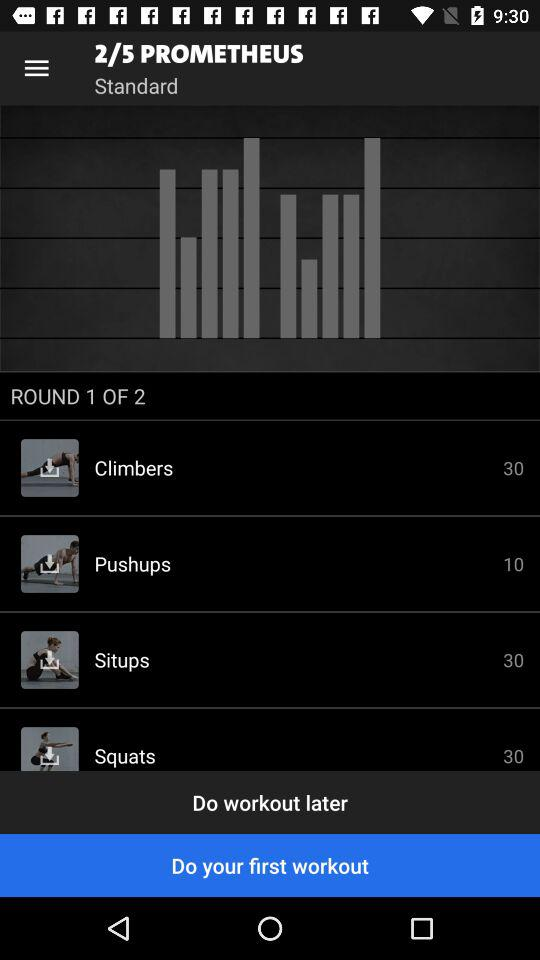How many workouts are completed in round 2?
When the provided information is insufficient, respond with <no answer>. <no answer> 